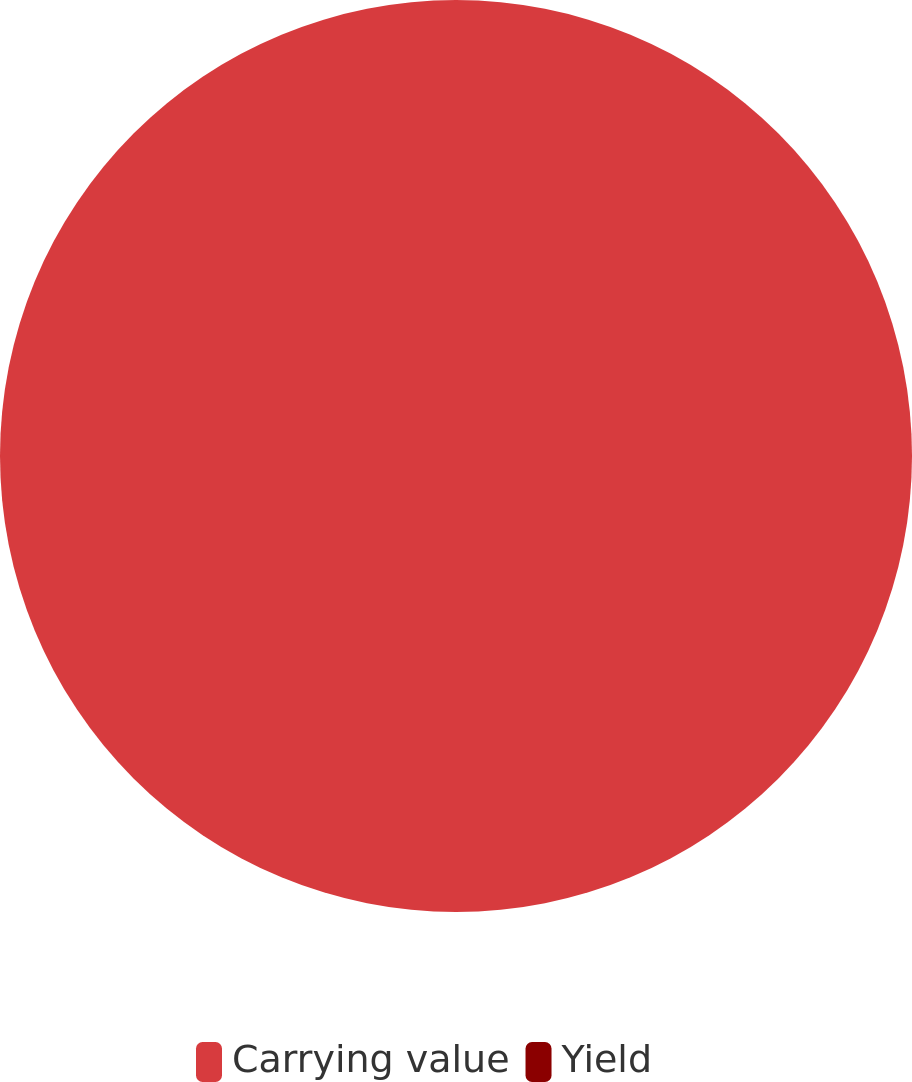Convert chart. <chart><loc_0><loc_0><loc_500><loc_500><pie_chart><fcel>Carrying value<fcel>Yield<nl><fcel>100.0%<fcel>0.0%<nl></chart> 